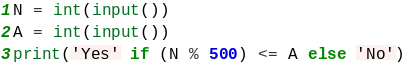Convert code to text. <code><loc_0><loc_0><loc_500><loc_500><_Python_>N = int(input())
A = int(input())
print('Yes' if (N % 500) <= A else 'No')</code> 